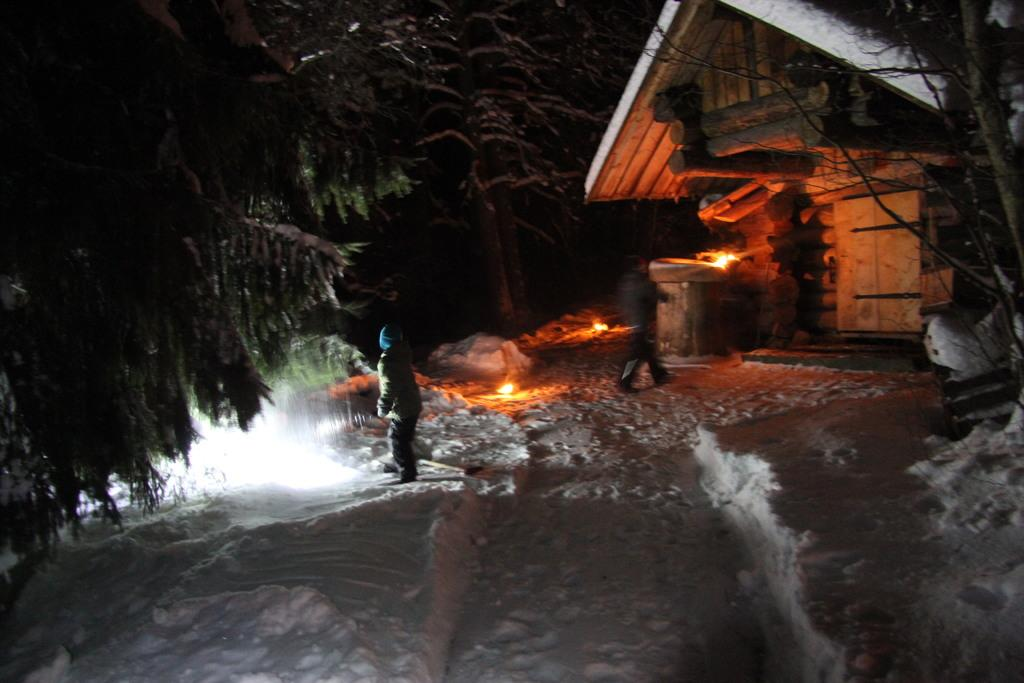What is the condition of the ground in the image? The ground is covered with snow in the image. What type of natural elements can be seen in the image? There are trees in the image. Are there any people visible in the image? Yes, there are persons standing in the image. What type of structure is present in the image? There is a wooden building in the image. Can you see any wounds on the persons standing in the image? There is no indication of any wounds on the persons standing in the image. What type of metal object is being used by the farmer in the image? There is no farmer or metal object present in the image. 